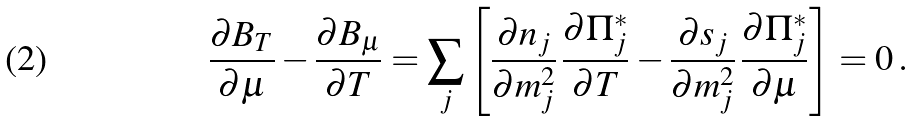Convert formula to latex. <formula><loc_0><loc_0><loc_500><loc_500>\frac { \partial B _ { T } } { \partial \mu } - \frac { \partial B _ { \mu } } { \partial T } = \sum _ { j } \left [ \frac { \partial n _ { j } } { \partial m _ { j } ^ { 2 } } \, \frac { \partial \Pi _ { j } ^ { * } } { \partial T } - \frac { \partial s _ { j } } { \partial m _ { j } ^ { 2 } } \, \frac { \partial \Pi _ { j } ^ { * } } { \partial \mu } \right ] = 0 \, .</formula> 